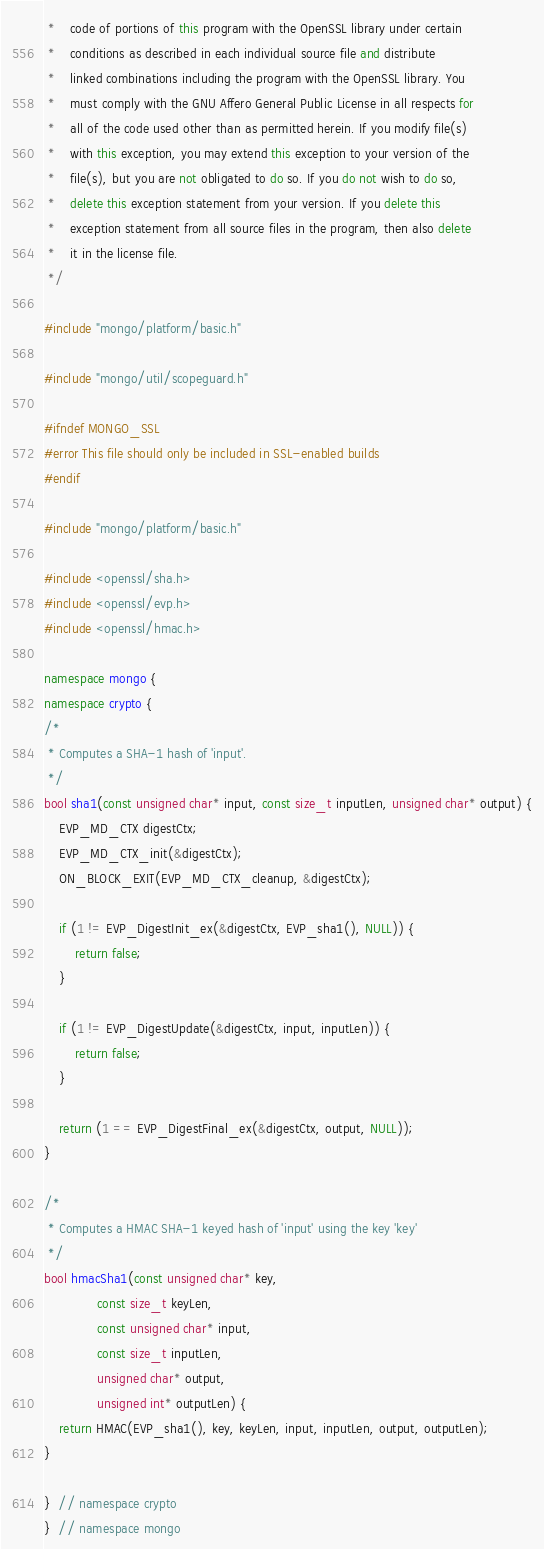Convert code to text. <code><loc_0><loc_0><loc_500><loc_500><_C++_> *    code of portions of this program with the OpenSSL library under certain
 *    conditions as described in each individual source file and distribute
 *    linked combinations including the program with the OpenSSL library. You
 *    must comply with the GNU Affero General Public License in all respects for
 *    all of the code used other than as permitted herein. If you modify file(s)
 *    with this exception, you may extend this exception to your version of the
 *    file(s), but you are not obligated to do so. If you do not wish to do so,
 *    delete this exception statement from your version. If you delete this
 *    exception statement from all source files in the program, then also delete
 *    it in the license file.
 */

#include "mongo/platform/basic.h"

#include "mongo/util/scopeguard.h"

#ifndef MONGO_SSL
#error This file should only be included in SSL-enabled builds
#endif

#include "mongo/platform/basic.h"

#include <openssl/sha.h>
#include <openssl/evp.h>
#include <openssl/hmac.h>

namespace mongo {
namespace crypto {
/*
 * Computes a SHA-1 hash of 'input'.
 */
bool sha1(const unsigned char* input, const size_t inputLen, unsigned char* output) {
    EVP_MD_CTX digestCtx;
    EVP_MD_CTX_init(&digestCtx);
    ON_BLOCK_EXIT(EVP_MD_CTX_cleanup, &digestCtx);

    if (1 != EVP_DigestInit_ex(&digestCtx, EVP_sha1(), NULL)) {
        return false;
    }

    if (1 != EVP_DigestUpdate(&digestCtx, input, inputLen)) {
        return false;
    }

    return (1 == EVP_DigestFinal_ex(&digestCtx, output, NULL));
}

/*
 * Computes a HMAC SHA-1 keyed hash of 'input' using the key 'key'
 */
bool hmacSha1(const unsigned char* key,
              const size_t keyLen,
              const unsigned char* input,
              const size_t inputLen,
              unsigned char* output,
              unsigned int* outputLen) {
    return HMAC(EVP_sha1(), key, keyLen, input, inputLen, output, outputLen);
}

}  // namespace crypto
}  // namespace mongo
</code> 